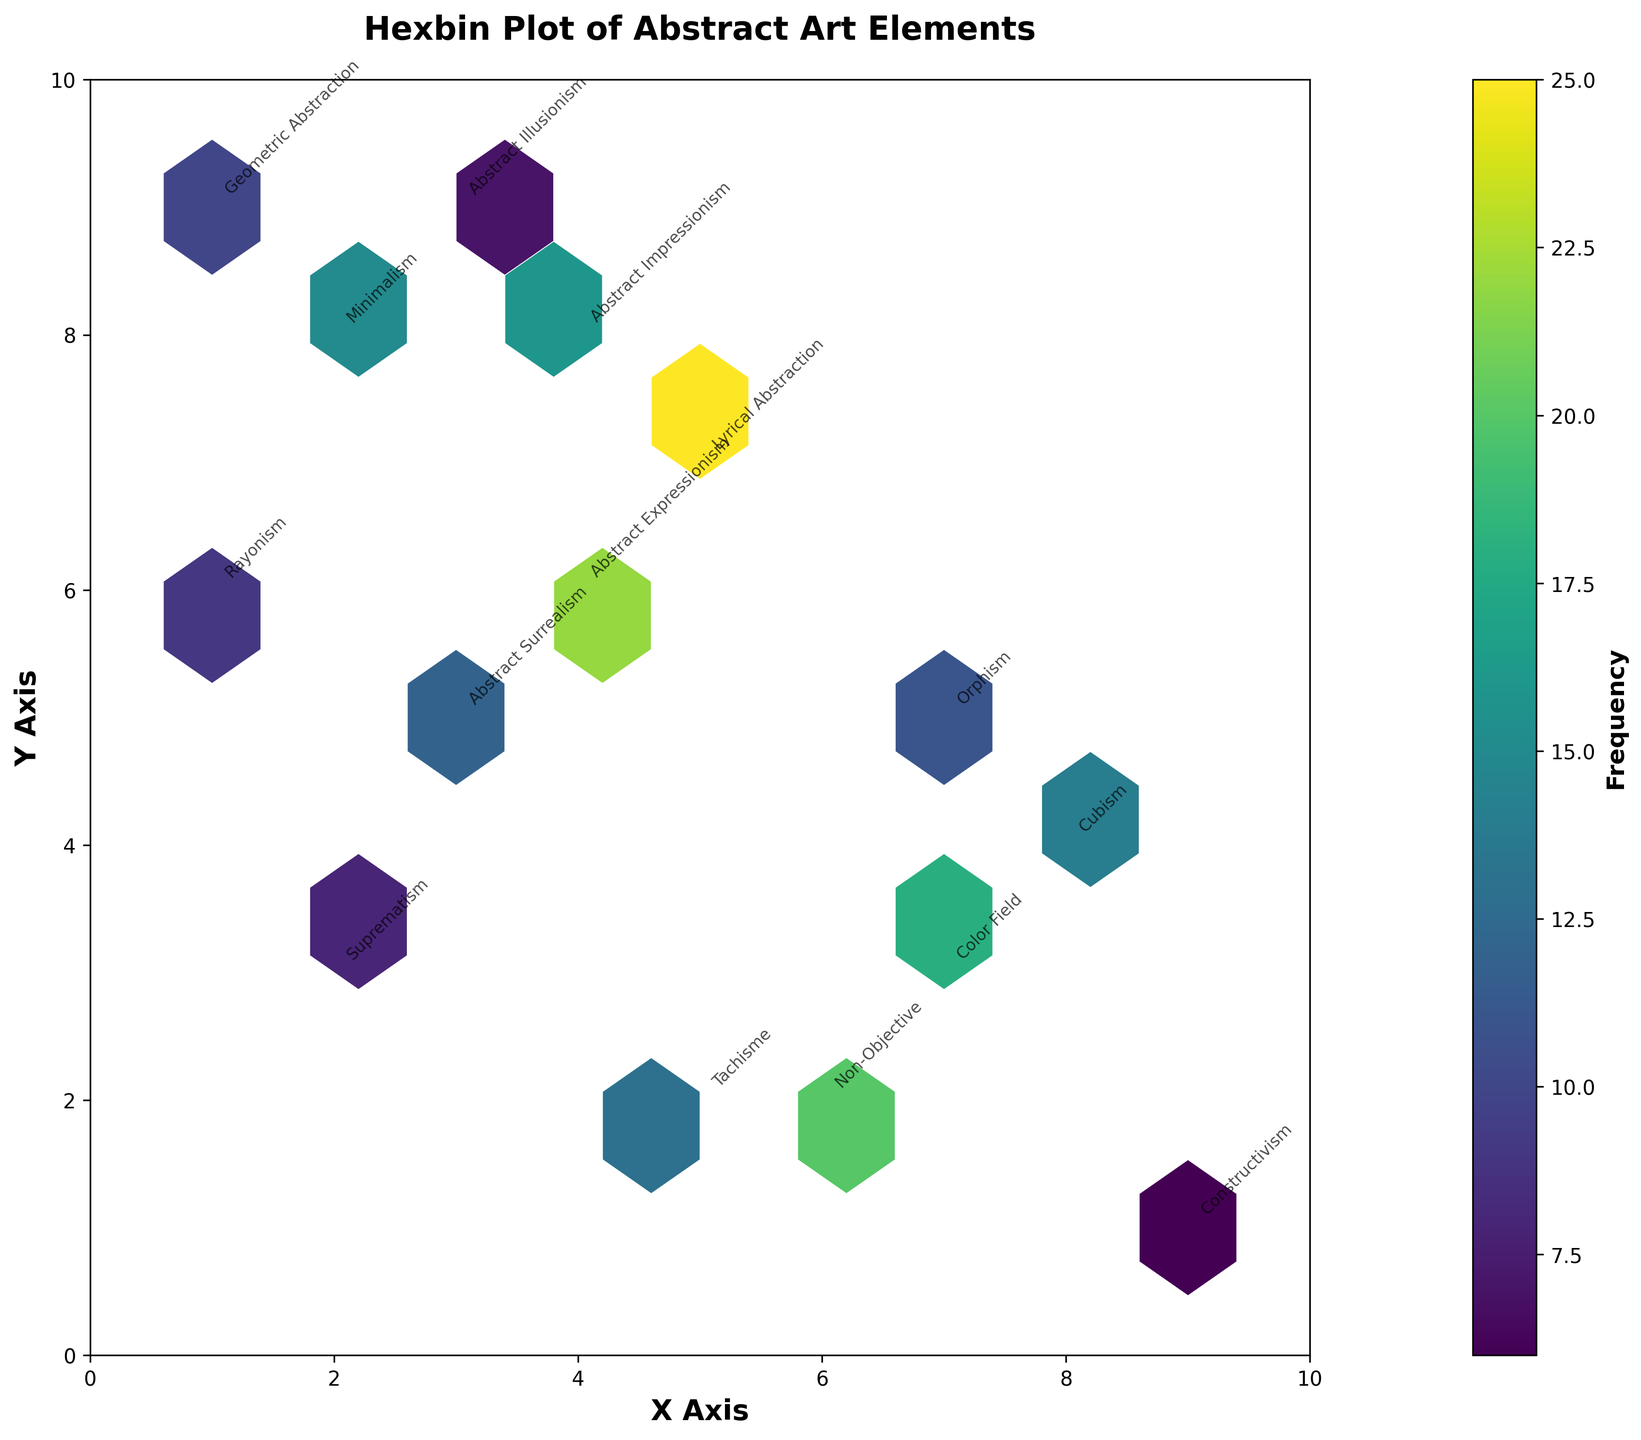What is the title of the hexbin plot? The title of a plot is usually placed at the top of the figure. In this case, the title specifically mentioned in the code is "Hexbin Plot of Abstract Art Elements".
Answer: Hexbin Plot of Abstract Art Elements What do the colors represent in the hexbin plot? The hexbin plot uses a color gradient to represent the frequency of abstract art elements. The colorbar indicates that darker shades mean higher frequencies.
Answer: Frequency Which medium has the highest frequency in the plot? By examining the hexbin cells and the annotated text for higher frequencies, the medium "Watercolor" has the highest frequency of 25, located at coordinates (5, 7).
Answer: Watercolor How many different styles of abstract art are represented in the plot? By counting the unique values in the 'style' column of the data provided, we see there's a variety including Minimalism, Abstract Expressionism, Geometric Abstraction, and others.
Answer: 15 Among the styles "Non-Objective" and "Tachisme," which one has a higher frequency? "Non-Objective" is at coordinates (6,2) with a frequency of 20, while "Tachisme" is at coordinates (5,2) with a frequency of 13. Therefore, "Non-Objective" has a higher frequency.
Answer: Non-Objective What is the frequency of Color Field, and where is it located in the plot? The frequency of "Color Field" can be found in the data or from the annotated text at coordinates (7, 3) with a frequency of 18.
Answer: 18, at (7, 3) Compare the frequencies of "Suprematism" and "Constructivism." Which one is higher and by how much? "Suprematism" has a frequency of 8 at coordinates (2,3), and "Constructivism" has a frequency of 6 at coordinates (9,1). The difference is 2.
Answer: Suprematism by 2 Which style has the lowest frequency, and what is that frequency? The data and annotations show that "Constructivism" has the lowest frequency of 6 at coordinates (9,1).
Answer: Constructivism, 6 What are the coordinates of the "Lyrical Abstraction" style? By locating the annotation "Lyrical Abstraction" on the hexbin plot, it is positioned at coordinates (5, 7).
Answer: (5, 7) What is the range of frequencies displayed in the hexbin plot? From the hexbin plot and colorbar, the range of frequencies spans from the lowest 6 ("Constructivism") to the highest 25 ("Watercolor").
Answer: 6 to 25 